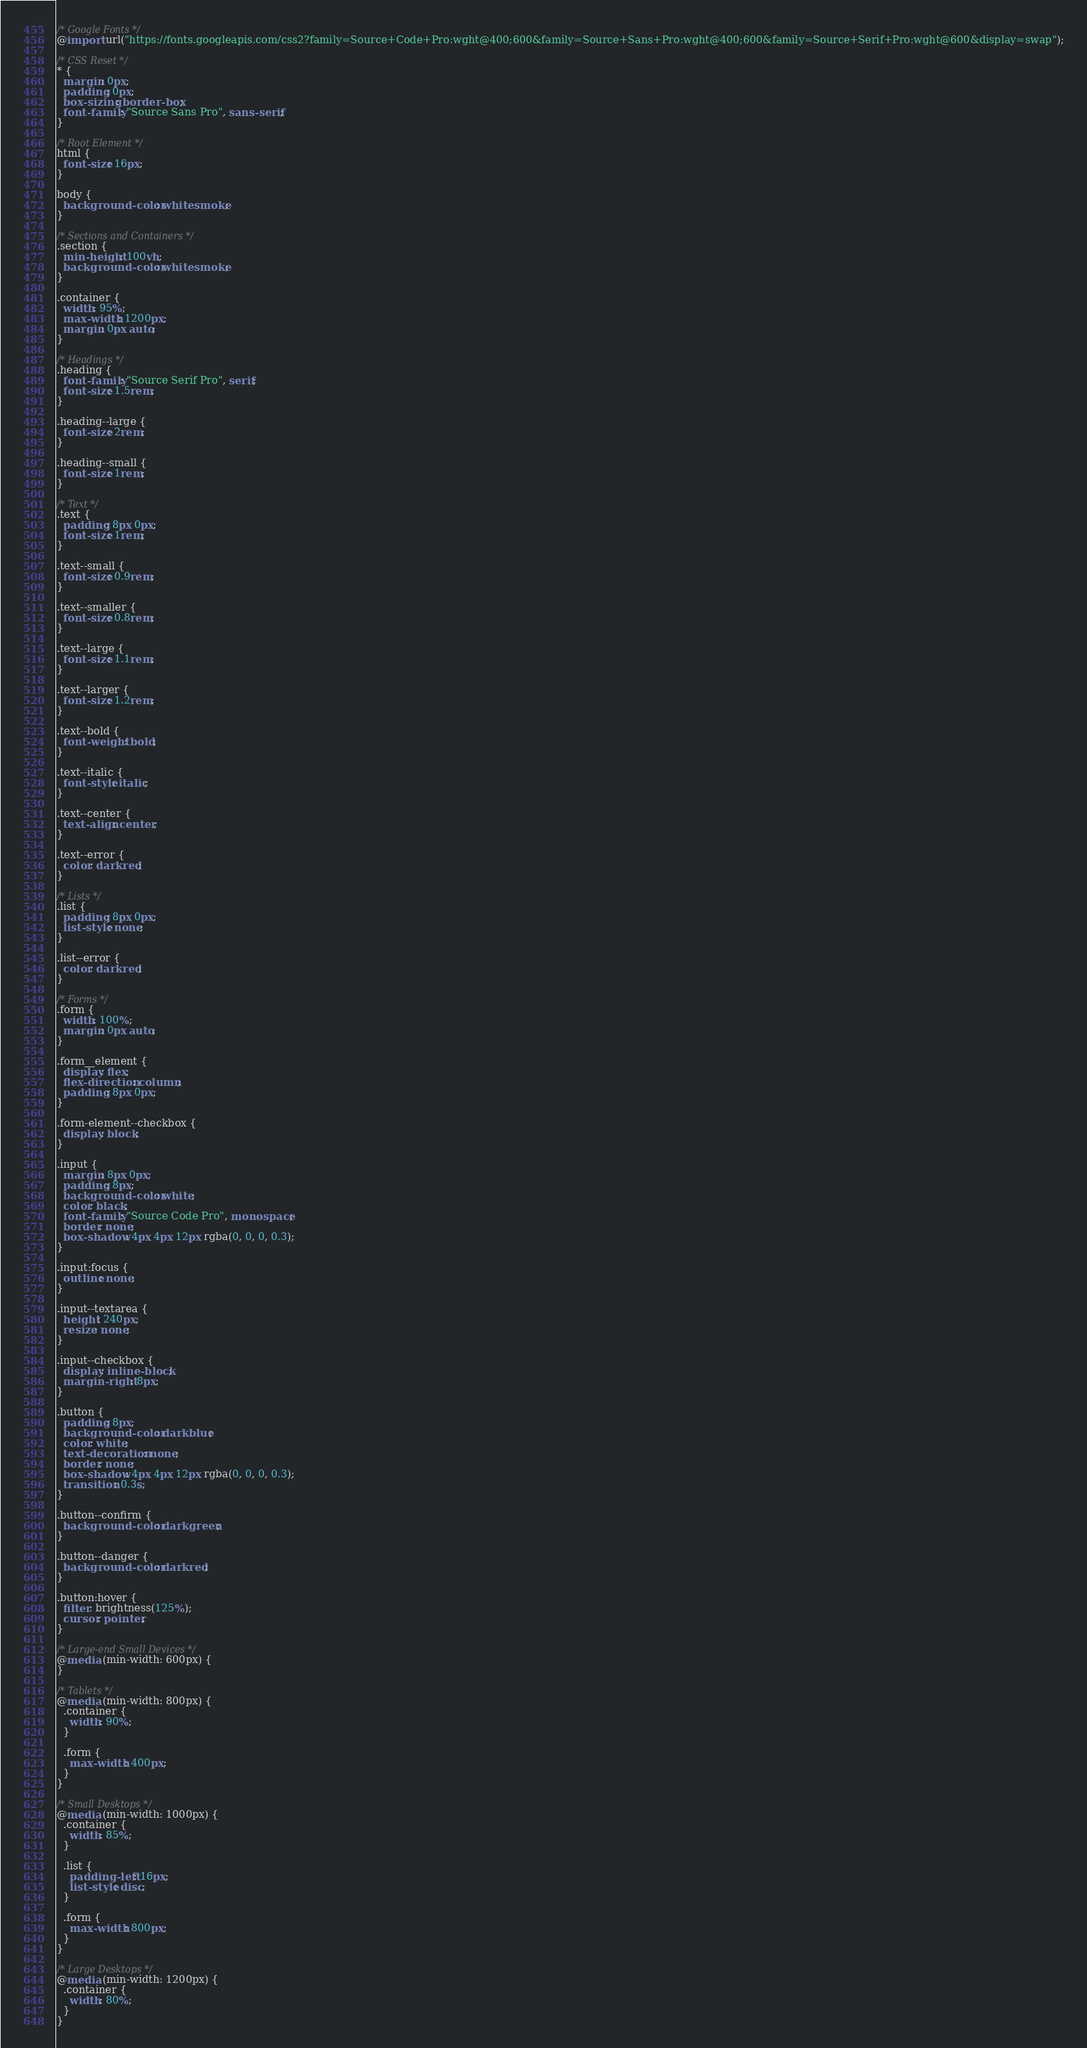Convert code to text. <code><loc_0><loc_0><loc_500><loc_500><_CSS_>/* Google Fonts */
@import url("https://fonts.googleapis.com/css2?family=Source+Code+Pro:wght@400;600&family=Source+Sans+Pro:wght@400;600&family=Source+Serif+Pro:wght@600&display=swap");

/* CSS Reset */
* {
  margin: 0px;
  padding: 0px;
  box-sizing: border-box;
  font-family: "Source Sans Pro", sans-serif;
}

/* Root Element */
html {
  font-size: 16px;
}

body {
  background-color: whitesmoke;
}

/* Sections and Containers */
.section {
  min-height: 100vh;
  background-color: whitesmoke;
}

.container {
  width: 95%;
  max-width: 1200px;
  margin: 0px auto;
}

/* Headings */
.heading {
  font-family: "Source Serif Pro", serif;
  font-size: 1.5rem;
}

.heading--large {
  font-size: 2rem;
}

.heading--small {
  font-size: 1rem;
}

/* Text */
.text {
  padding: 8px 0px;
  font-size: 1rem;
}

.text--small {
  font-size: 0.9rem;
}

.text--smaller {
  font-size: 0.8rem;
}

.text--large {
  font-size: 1.1rem;
}

.text--larger {
  font-size: 1.2rem;
}

.text--bold {
  font-weight: bold;
}

.text--italic {
  font-style: italic;
}

.text--center {
  text-align: center;
}

.text--error {
  color: darkred;
}

/* Lists */
.list {
  padding: 8px 0px;
  list-style: none;
}

.list--error {
  color: darkred;
}

/* Forms */
.form {
  width: 100%;
  margin: 0px auto;
}

.form__element {
  display: flex;
  flex-direction: column;
  padding: 8px 0px;
}

.form-element--checkbox {
  display: block;
}

.input {
  margin: 8px 0px;
  padding: 8px;
  background-color: white;
  color: black;
  font-family: "Source Code Pro", monospace;
  border: none;
  box-shadow: 4px 4px 12px rgba(0, 0, 0, 0.3);
}

.input:focus {
  outline: none;
}

.input--textarea {
  height: 240px;
  resize: none;
}

.input--checkbox {
  display: inline-block;
  margin-right: 8px;
}

.button {
  padding: 8px;
  background-color: darkblue;
  color: white;
  text-decoration: none;
  border: none;
  box-shadow: 4px 4px 12px rgba(0, 0, 0, 0.3);
  transition: 0.3s;
}

.button--confirm {
  background-color: darkgreen;
}

.button--danger {
  background-color: darkred;
}

.button:hover {
  filter: brightness(125%);
  cursor: pointer;
}

/* Large-end Small Devices */
@media (min-width: 600px) {
}

/* Tablets */
@media (min-width: 800px) {
  .container {
    width: 90%;
  }

  .form {
    max-width: 400px;
  }
}

/* Small Desktops */
@media (min-width: 1000px) {
  .container {
    width: 85%;
  }

  .list {
    padding-left: 16px;
    list-style: disc;
  }

  .form {
    max-width: 800px;
  }
}

/* Large Desktops */
@media (min-width: 1200px) {
  .container {
    width: 80%;
  }
}
</code> 